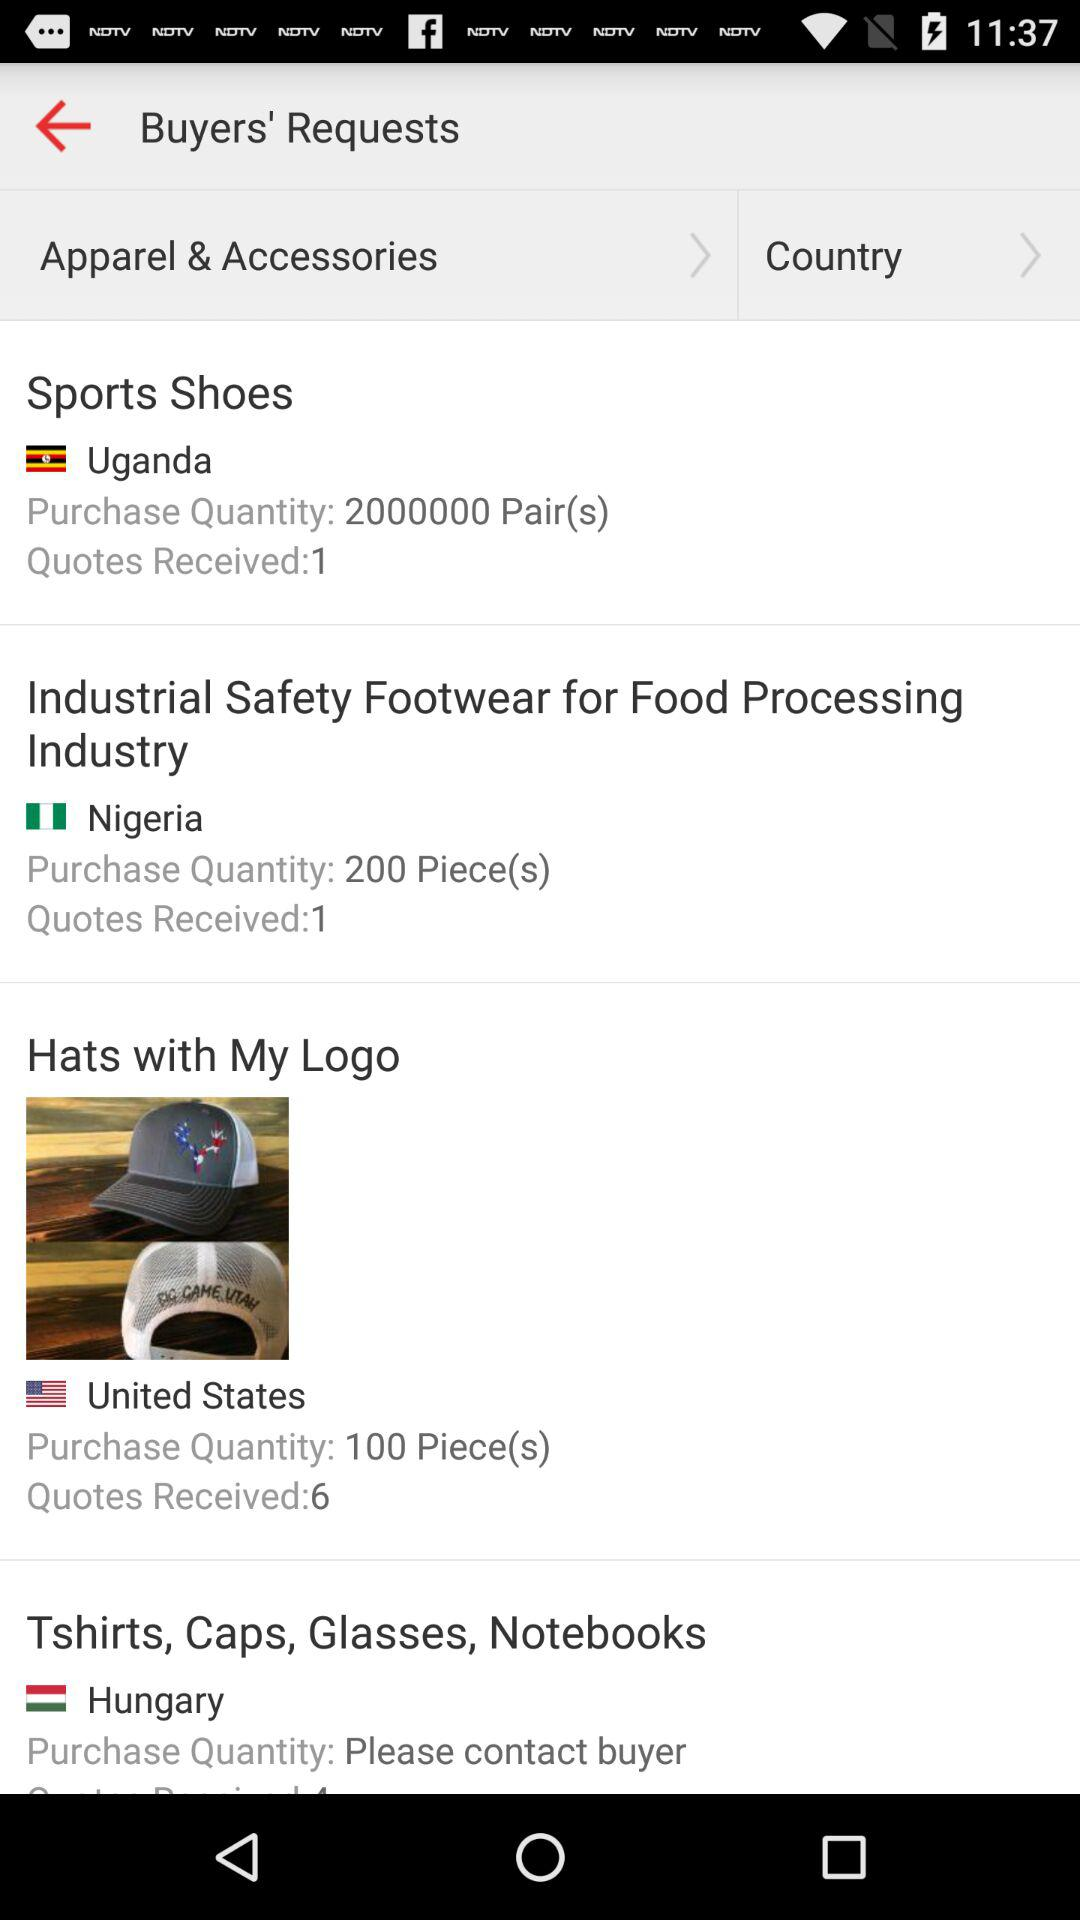How many quotes have been received from Uganda? The number of quotes that have been received from Uganda is 1. 